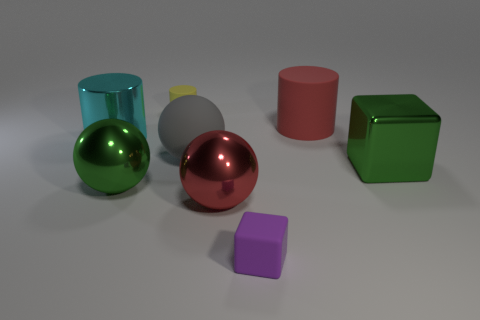What is the shape of the shiny thing that is the same color as the metal cube?
Your answer should be compact. Sphere. What number of small objects are either gray spheres or red rubber cylinders?
Keep it short and to the point. 0. What number of other things are there of the same size as the gray rubber object?
Make the answer very short. 5. There is a small matte object that is on the left side of the purple object; does it have the same shape as the purple object?
Provide a succinct answer. No. There is another small object that is the same shape as the red rubber thing; what is its color?
Provide a short and direct response. Yellow. Is there any other thing that has the same shape as the big cyan object?
Offer a terse response. Yes. Is the number of small yellow objects right of the big cyan thing the same as the number of small green shiny cylinders?
Offer a terse response. No. How many objects are both on the right side of the big gray sphere and in front of the big cyan cylinder?
Give a very brief answer. 3. There is a red metal object that is the same shape as the gray thing; what is its size?
Keep it short and to the point. Large. How many cyan cylinders have the same material as the green sphere?
Your response must be concise. 1. 